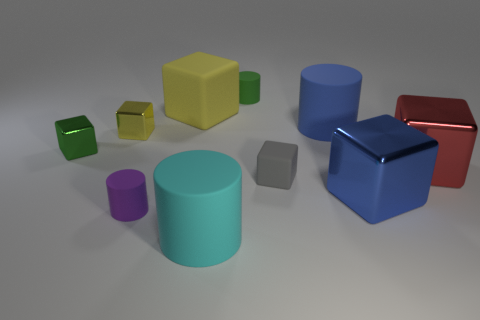Subtract all green cylinders. How many cylinders are left? 3 Subtract all purple cylinders. How many cylinders are left? 3 Subtract all cyan balls. How many yellow cubes are left? 2 Subtract all cubes. How many objects are left? 4 Subtract all red cylinders. Subtract all brown blocks. How many cylinders are left? 4 Subtract all big yellow rubber blocks. Subtract all big red objects. How many objects are left? 8 Add 6 gray cubes. How many gray cubes are left? 7 Add 9 small green rubber things. How many small green rubber things exist? 10 Subtract 1 blue blocks. How many objects are left? 9 Subtract 3 cylinders. How many cylinders are left? 1 